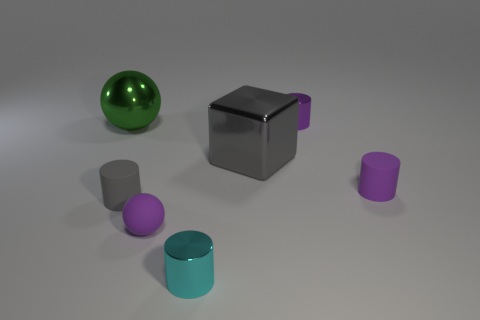Do the tiny cyan metallic thing and the small gray matte thing have the same shape?
Keep it short and to the point. Yes. The gray object that is made of the same material as the small purple ball is what shape?
Your response must be concise. Cylinder. What number of big objects are green spheres or blue things?
Ensure brevity in your answer.  1. Is there a cylinder on the left side of the small purple thing that is behind the gray metallic cube?
Keep it short and to the point. Yes. Are any purple matte spheres visible?
Make the answer very short. Yes. There is a small matte object in front of the tiny rubber cylinder on the left side of the small cyan cylinder; what is its color?
Provide a short and direct response. Purple. There is a small cyan thing that is the same shape as the purple shiny thing; what is it made of?
Offer a terse response. Metal. What number of metal spheres are the same size as the gray cube?
Offer a very short reply. 1. There is a sphere that is made of the same material as the big gray thing; what is its size?
Ensure brevity in your answer.  Large. What number of small purple metallic things are the same shape as the cyan metal thing?
Your response must be concise. 1. 